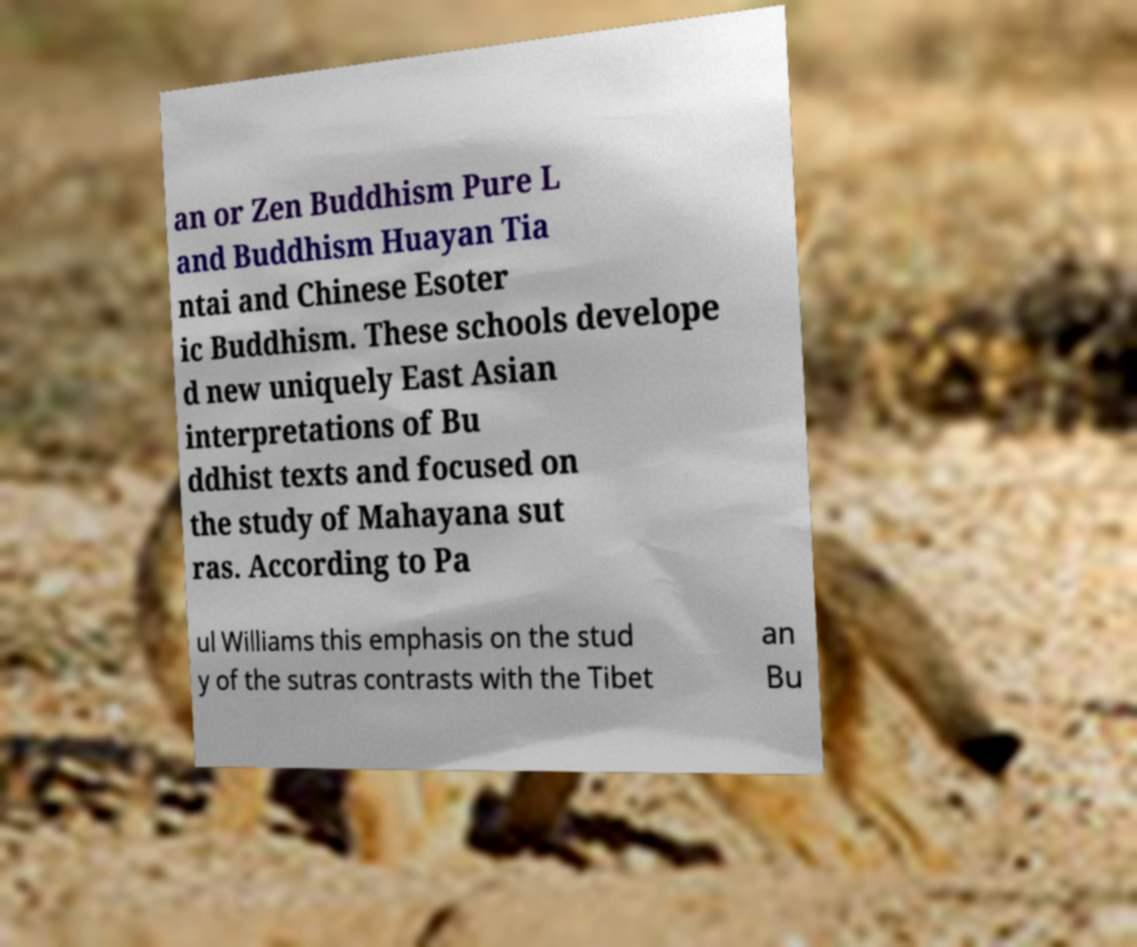Please read and relay the text visible in this image. What does it say? an or Zen Buddhism Pure L and Buddhism Huayan Tia ntai and Chinese Esoter ic Buddhism. These schools develope d new uniquely East Asian interpretations of Bu ddhist texts and focused on the study of Mahayana sut ras. According to Pa ul Williams this emphasis on the stud y of the sutras contrasts with the Tibet an Bu 